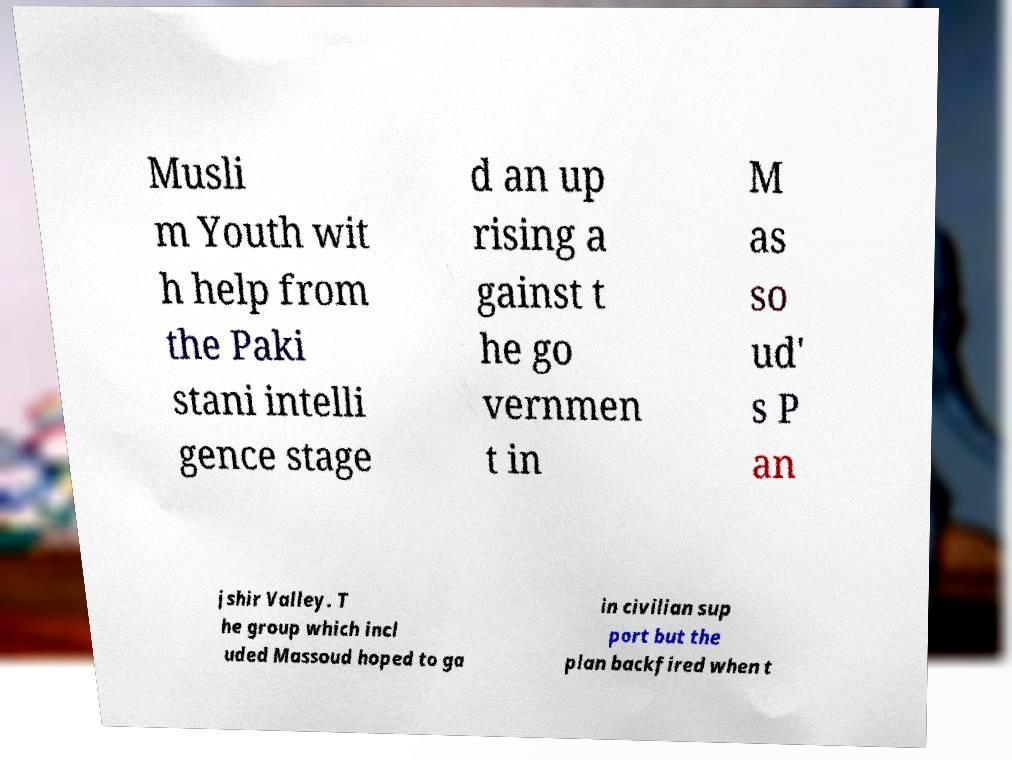For documentation purposes, I need the text within this image transcribed. Could you provide that? Musli m Youth wit h help from the Paki stani intelli gence stage d an up rising a gainst t he go vernmen t in M as so ud' s P an jshir Valley. T he group which incl uded Massoud hoped to ga in civilian sup port but the plan backfired when t 